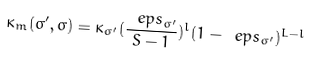Convert formula to latex. <formula><loc_0><loc_0><loc_500><loc_500>\kappa _ { m } ( \sigma ^ { \prime } , \sigma ) = \kappa _ { \sigma ^ { \prime } } ( \frac { \ e p s _ { \sigma ^ { \prime } } } { S - 1 } ) ^ { l } ( 1 - \ e p s _ { \sigma ^ { \prime } } ) ^ { L - l }</formula> 